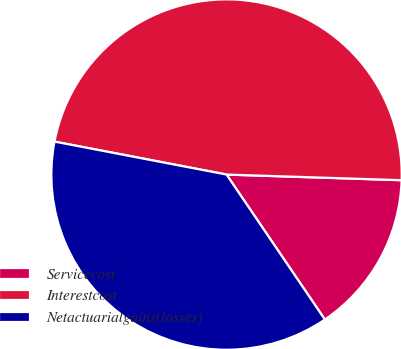<chart> <loc_0><loc_0><loc_500><loc_500><pie_chart><fcel>Servicecost<fcel>Interestcost<fcel>Netactuarialgains(losses)<nl><fcel>15.0%<fcel>47.5%<fcel>37.5%<nl></chart> 